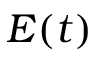Convert formula to latex. <formula><loc_0><loc_0><loc_500><loc_500>E ( t )</formula> 